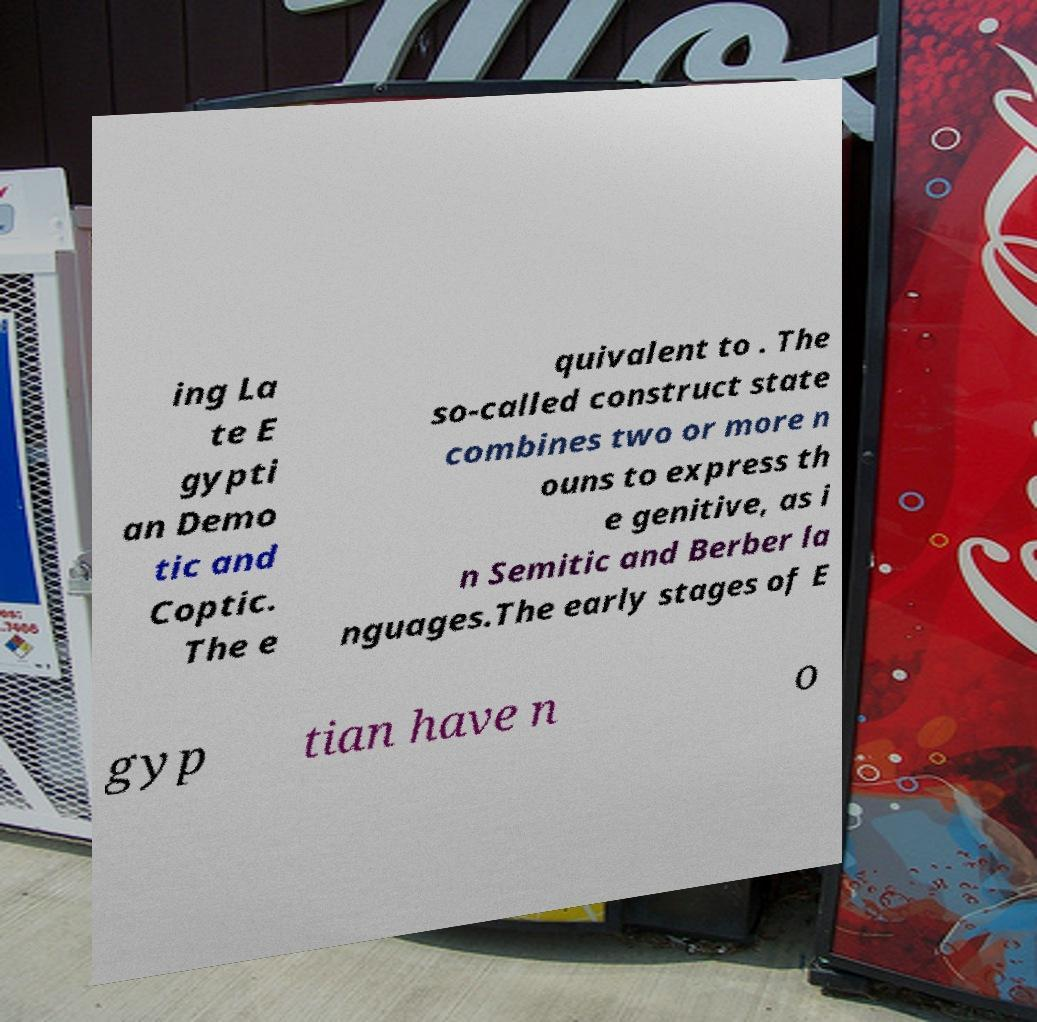Can you accurately transcribe the text from the provided image for me? ing La te E gypti an Demo tic and Coptic. The e quivalent to . The so-called construct state combines two or more n ouns to express th e genitive, as i n Semitic and Berber la nguages.The early stages of E gyp tian have n o 